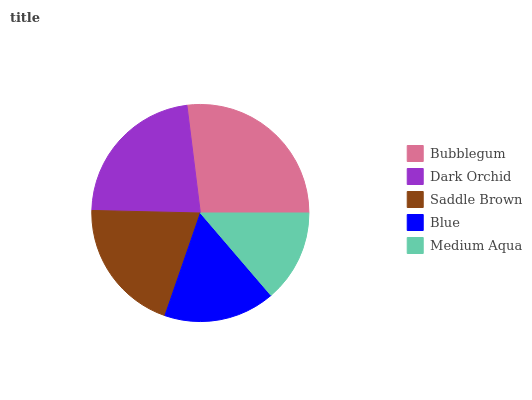Is Medium Aqua the minimum?
Answer yes or no. Yes. Is Bubblegum the maximum?
Answer yes or no. Yes. Is Dark Orchid the minimum?
Answer yes or no. No. Is Dark Orchid the maximum?
Answer yes or no. No. Is Bubblegum greater than Dark Orchid?
Answer yes or no. Yes. Is Dark Orchid less than Bubblegum?
Answer yes or no. Yes. Is Dark Orchid greater than Bubblegum?
Answer yes or no. No. Is Bubblegum less than Dark Orchid?
Answer yes or no. No. Is Saddle Brown the high median?
Answer yes or no. Yes. Is Saddle Brown the low median?
Answer yes or no. Yes. Is Medium Aqua the high median?
Answer yes or no. No. Is Blue the low median?
Answer yes or no. No. 